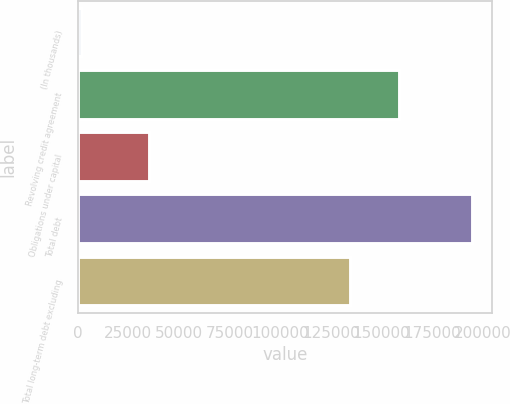Convert chart. <chart><loc_0><loc_0><loc_500><loc_500><bar_chart><fcel>(In thousands)<fcel>Revolving credit agreement<fcel>Obligations under capital<fcel>Total debt<fcel>Total long-term debt excluding<nl><fcel>2006<fcel>159263<fcel>35749<fcel>195012<fcel>134787<nl></chart> 